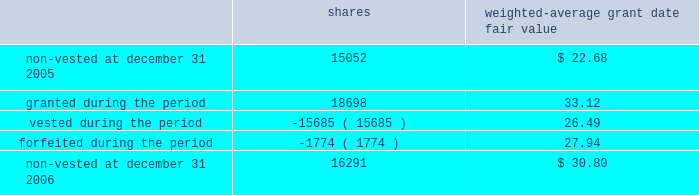O 2019 r e i l l y a u t o m o t i v e 2 0 0 6 a n n u a l r e p o r t p a g e 38 $ 11080000 , in the years ended december 31 , 2006 , 2005 and 2004 , respectively .
The remaining unrecognized compensation cost related to unvested awards at december 31 , 2006 , was $ 7702000 and the weighted-average period of time over which this cost will be recognized is 3.3 years .
Employee stock purchase plan the company 2019s employee stock purchase plan permits all eligible employees to purchase shares of the company 2019s common stock at 85% ( 85 % ) of the fair market value .
Participants may authorize the company to withhold up to 5% ( 5 % ) of their annual salary to participate in the plan .
The stock purchase plan authorizes up to 2600000 shares to be granted .
During the year ended december 31 , 2006 , the company issued 165306 shares under the purchase plan at a weighted average price of $ 27.36 per share .
During the year ended december 31 , 2005 , the company issued 161903 shares under the purchase plan at a weighted average price of $ 27.57 per share .
During the year ended december 31 , 2004 , the company issued 187754 shares under the purchase plan at a weighted average price of $ 20.85 per share .
Sfas no .
123r requires compensation expense to be recognized based on the discount between the grant date fair value and the employee purchase price for shares sold to employees .
During the year ended december 31 , 2006 , the company recorded $ 799000 of compensation cost related to employee share purchases and a corresponding income tax benefit of $ 295000 .
At december 31 , 2006 , approximately 400000 shares were reserved for future issuance .
Other employee benefit plans the company sponsors a contributory profit sharing and savings plan that covers substantially all employees who are at least 21 years of age and have at least six months of service .
The company has agreed to make matching contributions equal to 50% ( 50 % ) of the first 2% ( 2 % ) of each employee 2019s wages that are contributed and 25% ( 25 % ) of the next 4% ( 4 % ) of each employee 2019s wages that are contributed .
The company also makes additional discretionary profit sharing contributions to the plan on an annual basis as determined by the board of directors .
The company 2019s matching and profit sharing contributions under this plan are funded in the form of shares of the company 2019s common stock .
A total of 4200000 shares of common stock have been authorized for issuance under this plan .
During the year ended december 31 , 2006 , the company recorded $ 6429000 of compensation cost for contributions to this plan and a corresponding income tax benefit of $ 2372000 .
During the year ended december 31 , 2005 , the company recorded $ 6606000 of compensation cost for contributions to this plan and a corresponding income tax benefit of $ 2444000 .
During the year ended december 31 , 2004 , the company recorded $ 5278000 of compensation cost for contributions to this plan and a corresponding income tax benefit of $ 1969000 .
The compensation cost recorded in 2006 includes matching contributions made in 2006 and profit sharing contributions accrued in 2006 to be funded with issuance of shares of common stock in 2007 .
The company issued 204000 shares in 2006 to fund profit sharing and matching contributions at an average grant date fair value of $ 34.34 .
The company issued 210461 shares in 2005 to fund profit sharing and matching contributions at an average grant date fair value of $ 25.79 .
The company issued 238828 shares in 2004 to fund profit sharing and matching contributions at an average grant date fair value of $ 19.36 .
A portion of these shares related to profit sharing contributions accrued in prior periods .
At december 31 , 2006 , approximately 1061000 shares were reserved for future issuance under this plan .
The company has in effect a performance incentive plan for the company 2019s senior management under which the company awards shares of restricted stock that vest equally over a three-year period and are held in escrow until such vesting has occurred .
Shares are forfeited when an employee ceases employment .
A total of 800000 shares of common stock have been authorized for issuance under this plan .
Shares awarded under this plan are valued based on the market price of the company 2019s common stock on the date of grant and compensation cost is recorded over the vesting period .
The company recorded $ 416000 of compensation cost for this plan for the year ended december 31 , 2006 and recognized a corresponding income tax benefit of $ 154000 .
The company recorded $ 289000 of compensation cost for this plan for the year ended december 31 , 2005 and recognized a corresponding income tax benefit of $ 107000 .
The company recorded $ 248000 of compensation cost for this plan for the year ended december 31 , 2004 and recognized a corresponding income tax benefit of $ 93000 .
The total fair value of shares vested ( at vest date ) for the years ended december 31 , 2006 , 2005 and 2004 were $ 503000 , $ 524000 and $ 335000 , respectively .
The remaining unrecognized compensation cost related to unvested awards at december 31 , 2006 was $ 536000 .
The company awarded 18698 shares under this plan in 2006 with an average grant date fair value of $ 33.12 .
The company awarded 14986 shares under this plan in 2005 with an average grant date fair value of $ 25.41 .
The company awarded 15834 shares under this plan in 2004 with an average grant date fair value of $ 19.05 .
Compensation cost for shares awarded in 2006 will be recognized over the three-year vesting period .
Changes in the company 2019s restricted stock for the year ended december 31 , 2006 were as follows : weighted- average grant date shares fair value .
At december 31 , 2006 , approximately 659000 shares were reserved for future issuance under this plan .
N o t e s t o c o n s o l i d a t e d f i n a n c i a l s t a t e m e n t s ( cont inued ) .
What was the total value of the shares awarded under this plan in 2006 based on grant date value? 
Computations: (33.12 * 18698)
Answer: 619277.76. 